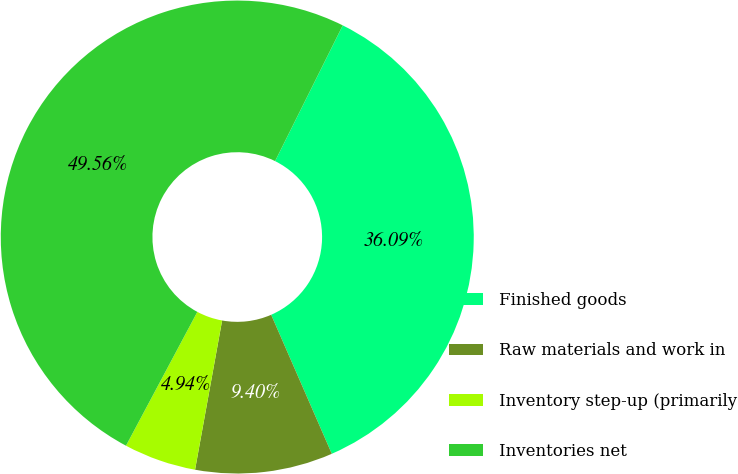Convert chart to OTSL. <chart><loc_0><loc_0><loc_500><loc_500><pie_chart><fcel>Finished goods<fcel>Raw materials and work in<fcel>Inventory step-up (primarily<fcel>Inventories net<nl><fcel>36.09%<fcel>9.4%<fcel>4.94%<fcel>49.56%<nl></chart> 